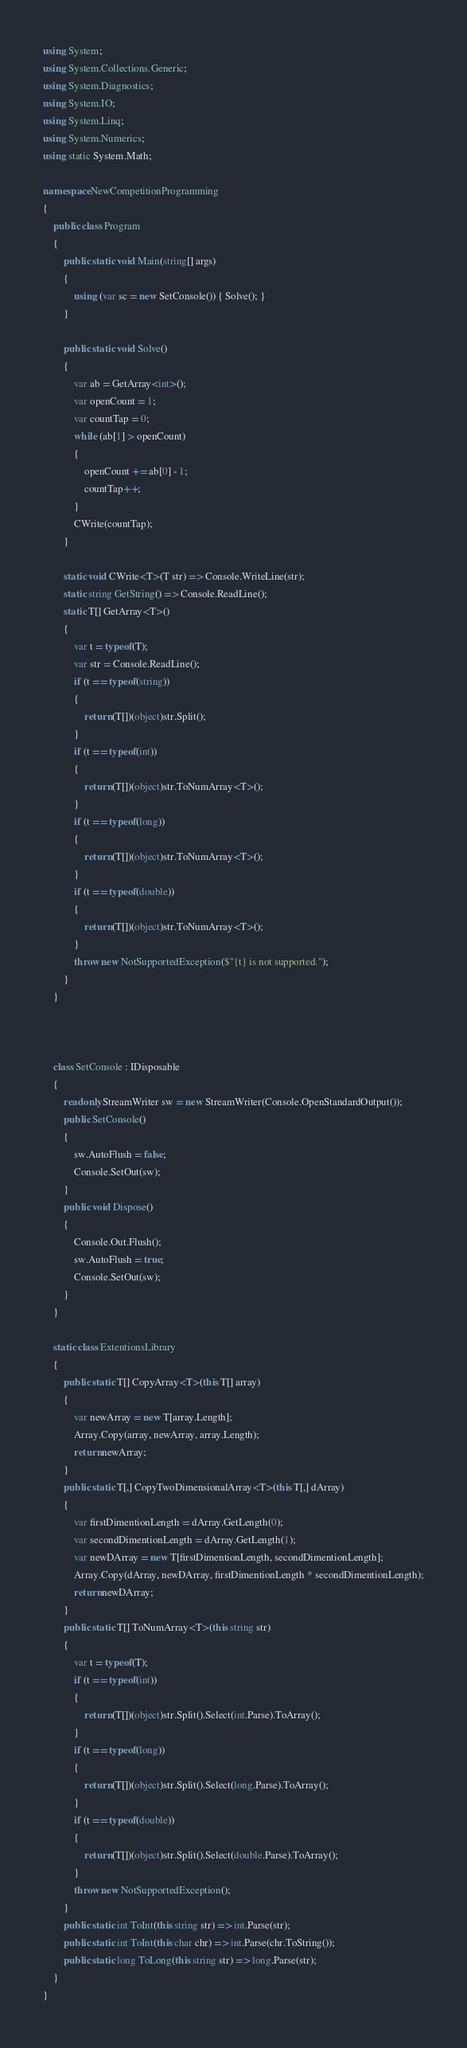Convert code to text. <code><loc_0><loc_0><loc_500><loc_500><_C#_>using System;
using System.Collections.Generic;
using System.Diagnostics;
using System.IO;
using System.Linq;
using System.Numerics;
using static System.Math;

namespace NewCompetitionProgramming
{
    public class Program
    {
        public static void Main(string[] args)
        {
            using (var sc = new SetConsole()) { Solve(); }
        }

        public static void Solve()
        {
            var ab = GetArray<int>();
            var openCount = 1;
            var countTap = 0;
            while (ab[1] > openCount)
            {
                openCount += ab[0] - 1;
                countTap++;
            }
            CWrite(countTap);
        }

        static void CWrite<T>(T str) => Console.WriteLine(str);
        static string GetString() => Console.ReadLine();
        static T[] GetArray<T>()
        {
            var t = typeof(T);
            var str = Console.ReadLine();
            if (t == typeof(string))
            {
                return (T[])(object)str.Split();
            }
            if (t == typeof(int))
            {
                return (T[])(object)str.ToNumArray<T>();
            }
            if (t == typeof(long))
            {
                return (T[])(object)str.ToNumArray<T>();
            }
            if (t == typeof(double))
            {
                return (T[])(object)str.ToNumArray<T>();
            }
            throw new NotSupportedException($"{t} is not supported.");
        }
    }



    class SetConsole : IDisposable
    {
        readonly StreamWriter sw = new StreamWriter(Console.OpenStandardOutput());
        public SetConsole()
        {
            sw.AutoFlush = false;
            Console.SetOut(sw);
        }
        public void Dispose()
        {
            Console.Out.Flush();
            sw.AutoFlush = true;
            Console.SetOut(sw);
        }
    }

    static class ExtentionsLibrary
    {
        public static T[] CopyArray<T>(this T[] array)
        {
            var newArray = new T[array.Length];
            Array.Copy(array, newArray, array.Length);
            return newArray;
        }
        public static T[,] CopyTwoDimensionalArray<T>(this T[,] dArray)
        {
            var firstDimentionLength = dArray.GetLength(0);
            var secondDimentionLength = dArray.GetLength(1);
            var newDArray = new T[firstDimentionLength, secondDimentionLength];
            Array.Copy(dArray, newDArray, firstDimentionLength * secondDimentionLength);
            return newDArray;
        }
        public static T[] ToNumArray<T>(this string str)
        {
            var t = typeof(T);
            if (t == typeof(int))
            {
                return (T[])(object)str.Split().Select(int.Parse).ToArray();
            }
            if (t == typeof(long))
            {
                return (T[])(object)str.Split().Select(long.Parse).ToArray();
            }
            if (t == typeof(double))
            {
                return (T[])(object)str.Split().Select(double.Parse).ToArray();
            }
            throw new NotSupportedException();
        }
        public static int ToInt(this string str) => int.Parse(str);
        public static int ToInt(this char chr) => int.Parse(chr.ToString());
        public static long ToLong(this string str) => long.Parse(str);
    }
}
</code> 